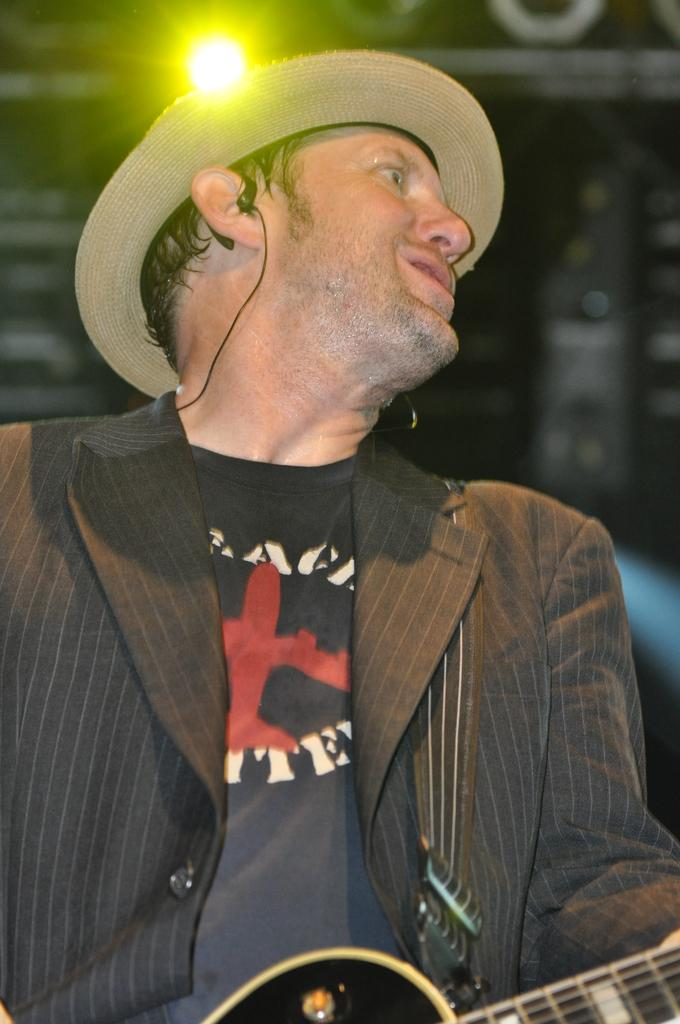What is the main subject of the image? The main subject of the image is a man. What is the man holding in the image? The man is holding a guitar. What type of corn is being harvested by the man in the image? There is no corn present in the image; the man is holding a guitar. How many trucks can be seen in the background of the image? There are no trucks visible in the image; it only features a man holding a guitar. 